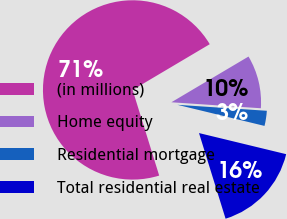Convert chart. <chart><loc_0><loc_0><loc_500><loc_500><pie_chart><fcel>(in millions)<fcel>Home equity<fcel>Residential mortgage<fcel>Total residential real estate<nl><fcel>71.27%<fcel>9.58%<fcel>2.72%<fcel>16.43%<nl></chart> 